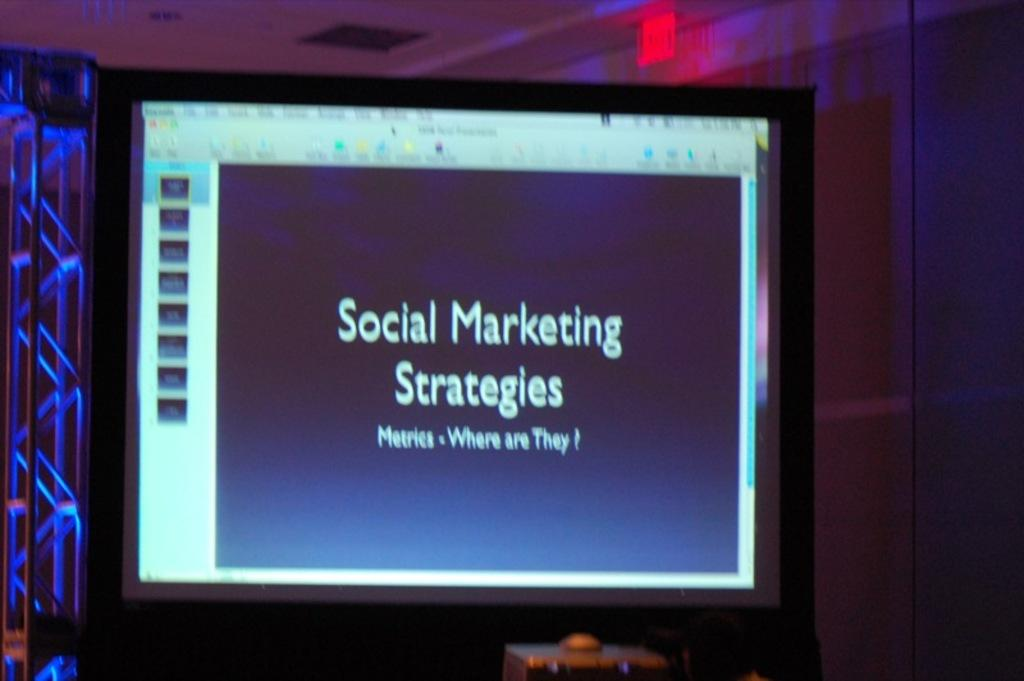Provide a one-sentence caption for the provided image. A screen with Social Marketing Strategies on a slide. 